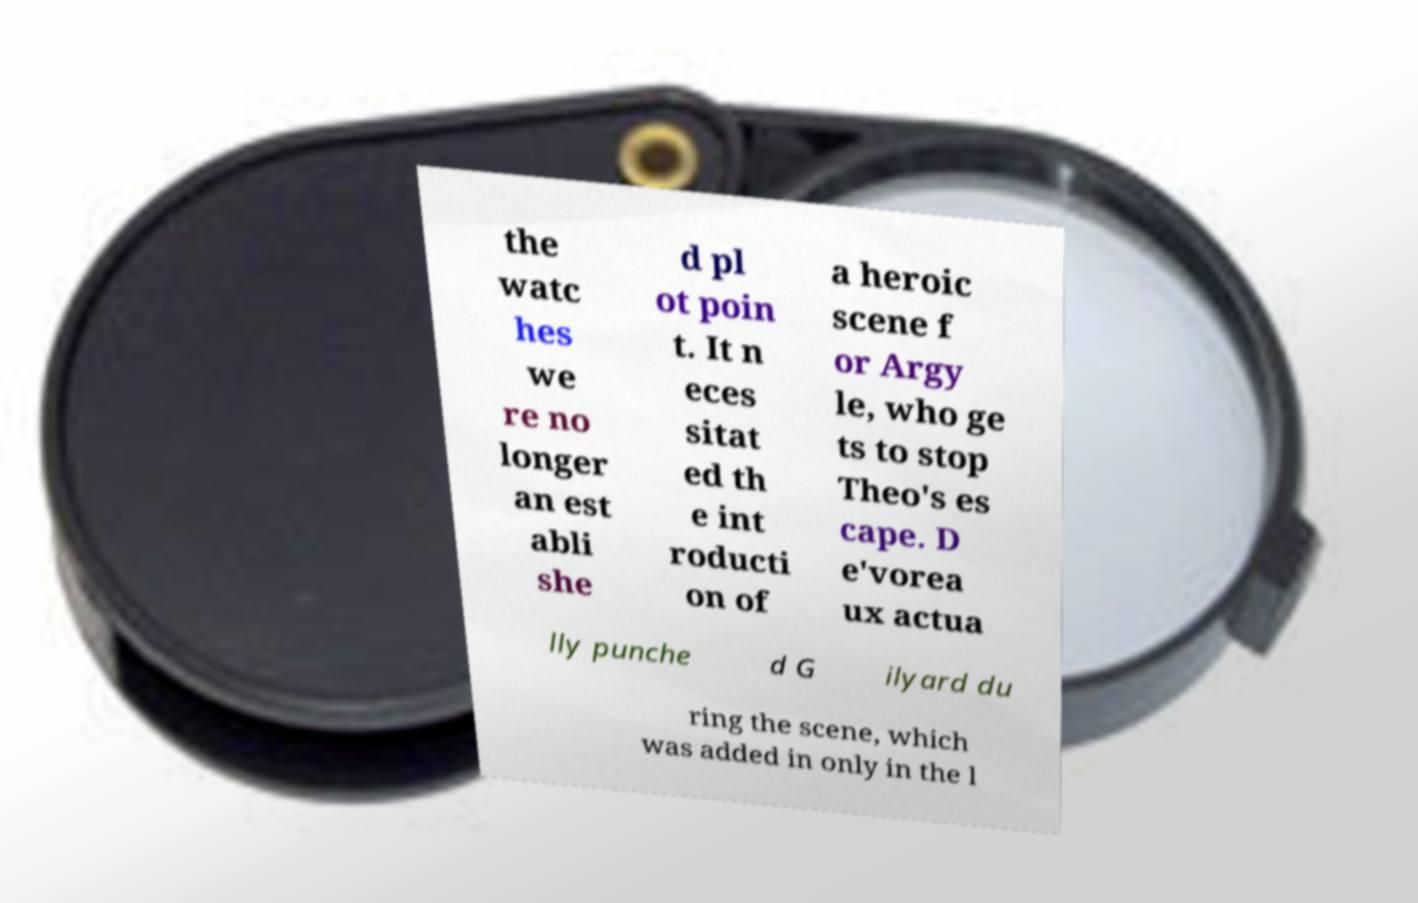Please read and relay the text visible in this image. What does it say? the watc hes we re no longer an est abli she d pl ot poin t. It n eces sitat ed th e int roducti on of a heroic scene f or Argy le, who ge ts to stop Theo's es cape. D e'vorea ux actua lly punche d G ilyard du ring the scene, which was added in only in the l 